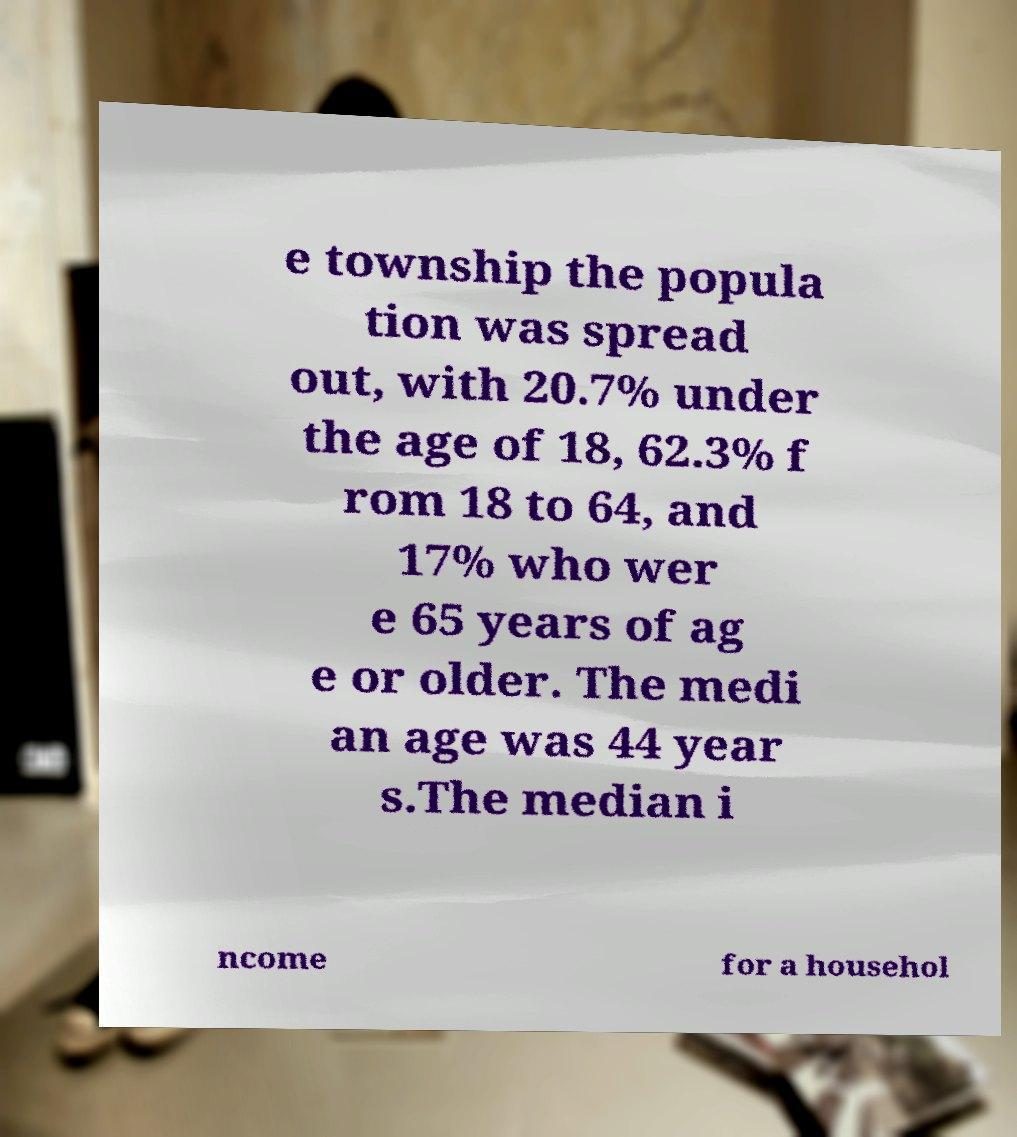What messages or text are displayed in this image? I need them in a readable, typed format. e township the popula tion was spread out, with 20.7% under the age of 18, 62.3% f rom 18 to 64, and 17% who wer e 65 years of ag e or older. The medi an age was 44 year s.The median i ncome for a househol 